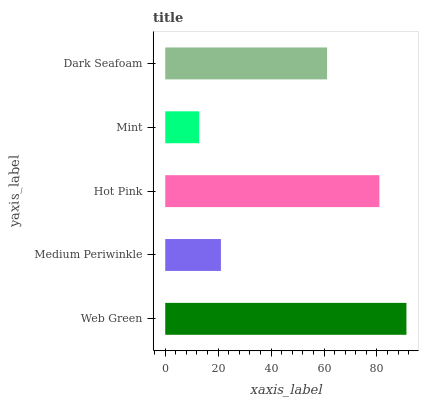Is Mint the minimum?
Answer yes or no. Yes. Is Web Green the maximum?
Answer yes or no. Yes. Is Medium Periwinkle the minimum?
Answer yes or no. No. Is Medium Periwinkle the maximum?
Answer yes or no. No. Is Web Green greater than Medium Periwinkle?
Answer yes or no. Yes. Is Medium Periwinkle less than Web Green?
Answer yes or no. Yes. Is Medium Periwinkle greater than Web Green?
Answer yes or no. No. Is Web Green less than Medium Periwinkle?
Answer yes or no. No. Is Dark Seafoam the high median?
Answer yes or no. Yes. Is Dark Seafoam the low median?
Answer yes or no. Yes. Is Medium Periwinkle the high median?
Answer yes or no. No. Is Medium Periwinkle the low median?
Answer yes or no. No. 